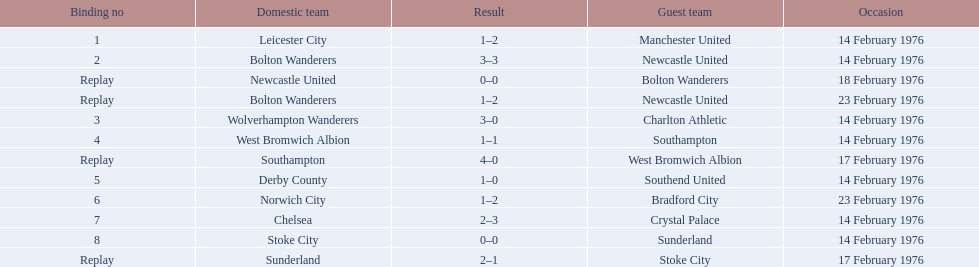What are all of the scores of the 1975-76 fa cup? 1–2, 3–3, 0–0, 1–2, 3–0, 1–1, 4–0, 1–0, 1–2, 2–3, 0–0, 2–1. What are the scores for manchester united or wolverhampton wanderers? 1–2, 3–0. Which has the highest score? 3–0. Who was this score for? Wolverhampton Wanderers. 